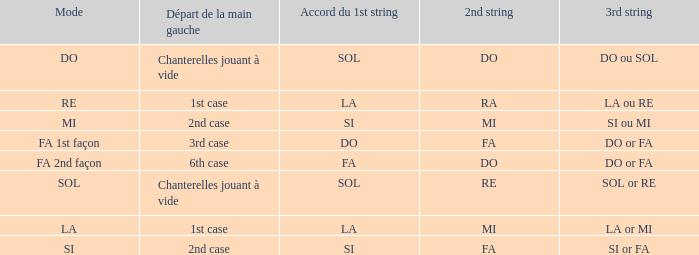For the 2nd string of Ra what is the Depart de la main gauche? 1st case. 